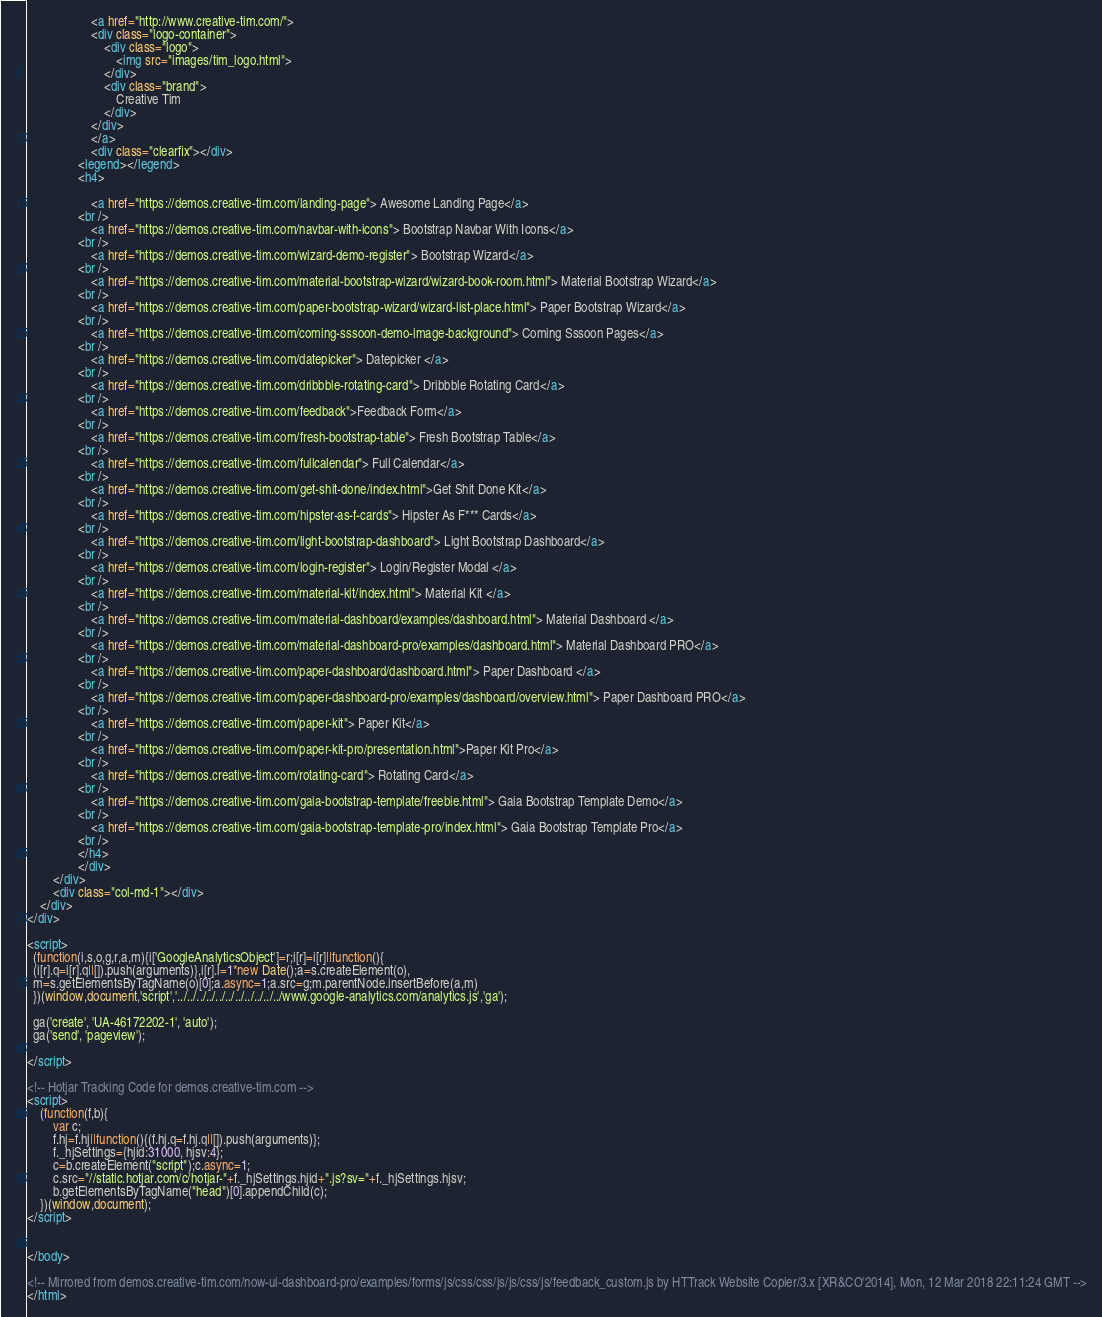<code> <loc_0><loc_0><loc_500><loc_500><_HTML_>                    <a href="http://www.creative-tim.com/">
                    <div class="logo-container">
                        <div class="logo">
                            <img src="images/tim_logo.html">
                        </div>
                        <div class="brand">
                            Creative Tim
                        </div>
                    </div>
                    </a>
                    <div class="clearfix"></div>
                <legend></legend>
                <h4>

                    <a href="https://demos.creative-tim.com/landing-page"> Awesome Landing Page</a>
                <br />
                    <a href="https://demos.creative-tim.com/navbar-with-icons"> Bootstrap Navbar With Icons</a>
                <br />
                    <a href="https://demos.creative-tim.com/wizard-demo-register"> Bootstrap Wizard</a>
                <br />
					<a href="https://demos.creative-tim.com/material-bootstrap-wizard/wizard-book-room.html"> Material Bootstrap Wizard</a>
				<br />
					<a href="https://demos.creative-tim.com/paper-bootstrap-wizard/wizard-list-place.html"> Paper Bootstrap Wizard</a>
				<br />
                    <a href="https://demos.creative-tim.com/coming-sssoon-demo-image-background"> Coming Sssoon Pages</a>
                <br />
                    <a href="https://demos.creative-tim.com/datepicker"> Datepicker </a>
                <br />
                    <a href="https://demos.creative-tim.com/dribbble-rotating-card"> Dribbble Rotating Card</a>
                <br />
                    <a href="https://demos.creative-tim.com/feedback">Feedback Form</a>
                <br />
                    <a href="https://demos.creative-tim.com/fresh-bootstrap-table"> Fresh Bootstrap Table</a>
                <br />
                    <a href="https://demos.creative-tim.com/fullcalendar"> Full Calendar</a>
                <br />
                    <a href="https://demos.creative-tim.com/get-shit-done/index.html">Get Shit Done Kit</a>
                <br />
                    <a href="https://demos.creative-tim.com/hipster-as-f-cards"> Hipster As F*** Cards</a>
                <br />
                    <a href="https://demos.creative-tim.com/light-bootstrap-dashboard"> Light Bootstrap Dashboard</a>
                <br />
                    <a href="https://demos.creative-tim.com/login-register"> Login/Register Modal </a>
                <br />
                    <a href="https://demos.creative-tim.com/material-kit/index.html"> Material Kit </a>
				<br />
					<a href="https://demos.creative-tim.com/material-dashboard/examples/dashboard.html"> Material Dashboard </a>
				<br />
					<a href="https://demos.creative-tim.com/material-dashboard-pro/examples/dashboard.html"> Material Dashboard PRO</a>
				<br />
                    <a href="https://demos.creative-tim.com/paper-dashboard/dashboard.html"> Paper Dashboard </a>
				<br />
				    <a href="https://demos.creative-tim.com/paper-dashboard-pro/examples/dashboard/overview.html"> Paper Dashboard PRO</a>
				<br />
                    <a href="https://demos.creative-tim.com/paper-kit"> Paper Kit</a>
				<br />
                    <a href="https://demos.creative-tim.com/paper-kit-pro/presentation.html">Paper Kit Pro</a>
                <br />
                    <a href="https://demos.creative-tim.com/rotating-card"> Rotating Card</a>
				<br />
					<a href="https://demos.creative-tim.com/gaia-bootstrap-template/freebie.html"> Gaia Bootstrap Template Demo</a>
                <br />
					<a href="https://demos.creative-tim.com/gaia-bootstrap-template-pro/index.html"> Gaia Bootstrap Template Pro</a>
				<br />
                </h4>
                </div>
        </div>
        <div class="col-md-1"></div>
    </div>
</div>

<script>
  (function(i,s,o,g,r,a,m){i['GoogleAnalyticsObject']=r;i[r]=i[r]||function(){
  (i[r].q=i[r].q||[]).push(arguments)},i[r].l=1*new Date();a=s.createElement(o),
  m=s.getElementsByTagName(o)[0];a.async=1;a.src=g;m.parentNode.insertBefore(a,m)
  })(window,document,'script','../../../../../../../../../../../www.google-analytics.com/analytics.js','ga');

  ga('create', 'UA-46172202-1', 'auto');
  ga('send', 'pageview');

</script>

<!-- Hotjar Tracking Code for demos.creative-tim.com -->
<script>
    (function(f,b){
        var c;
        f.hj=f.hj||function(){(f.hj.q=f.hj.q||[]).push(arguments)};
        f._hjSettings={hjid:31000, hjsv:4};
        c=b.createElement("script");c.async=1;
        c.src="//static.hotjar.com/c/hotjar-"+f._hjSettings.hjid+".js?sv="+f._hjSettings.hjsv;
        b.getElementsByTagName("head")[0].appendChild(c);
    })(window,document);
</script>


</body>

<!-- Mirrored from demos.creative-tim.com/now-ui-dashboard-pro/examples/forms/js/css/css/js/js/css/js/feedback_custom.js by HTTrack Website Copier/3.x [XR&CO'2014], Mon, 12 Mar 2018 22:11:24 GMT -->
</html>
</code> 